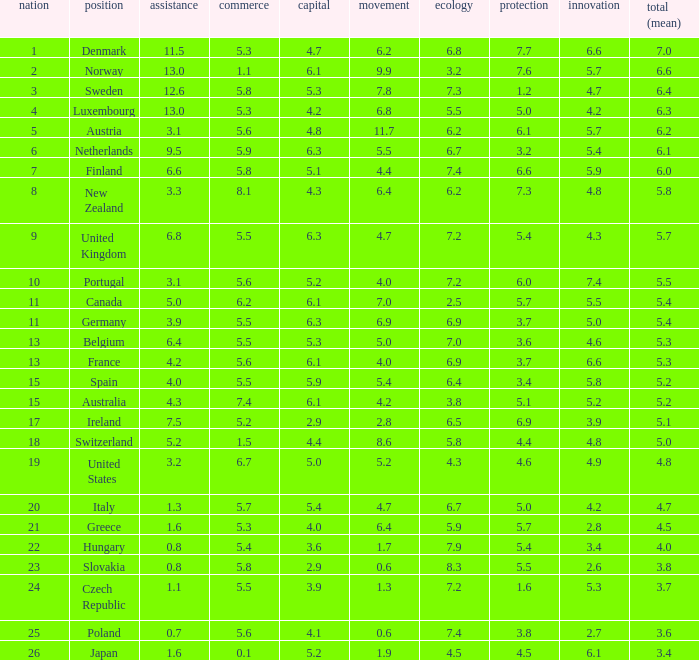How many times is denmark ranked in technology? 1.0. 